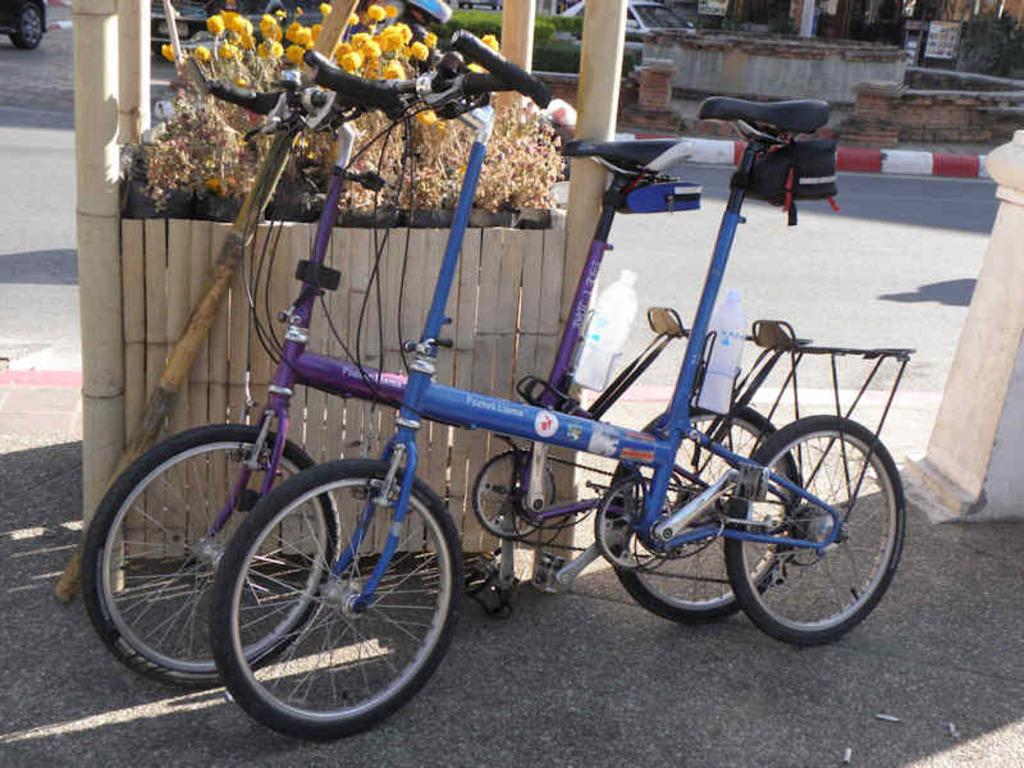Where was the image taken? The image was clicked outside. What can be seen at the top of the image? There are flowers and a car at the top of the image. What is located in the middle of the image? There are cycles and water bottles in the middle of the image. What language is spoken by the flowers in the image? The flowers do not speak a language, as they are plants and not capable of speech. 